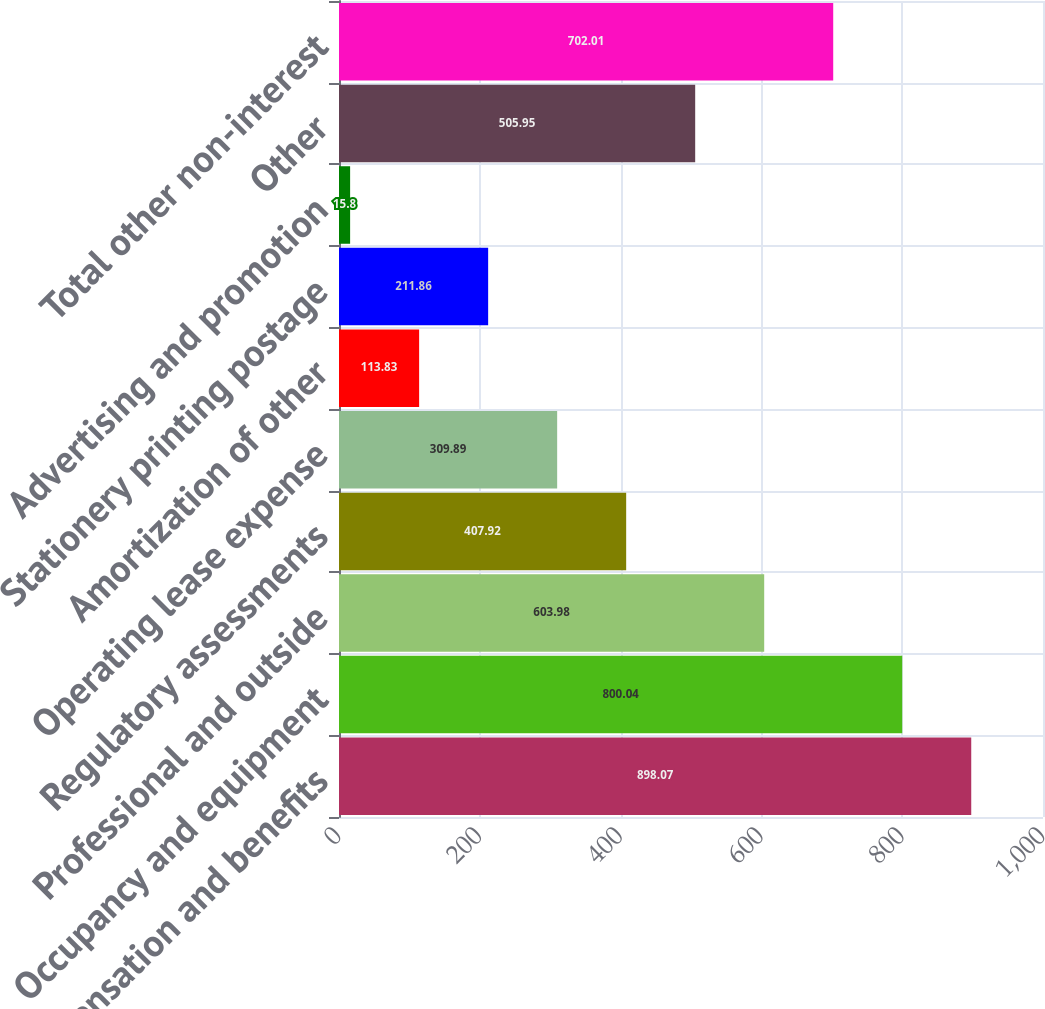Convert chart. <chart><loc_0><loc_0><loc_500><loc_500><bar_chart><fcel>Compensation and benefits<fcel>Occupancy and equipment<fcel>Professional and outside<fcel>Regulatory assessments<fcel>Operating lease expense<fcel>Amortization of other<fcel>Stationery printing postage<fcel>Advertising and promotion<fcel>Other<fcel>Total other non-interest<nl><fcel>898.07<fcel>800.04<fcel>603.98<fcel>407.92<fcel>309.89<fcel>113.83<fcel>211.86<fcel>15.8<fcel>505.95<fcel>702.01<nl></chart> 